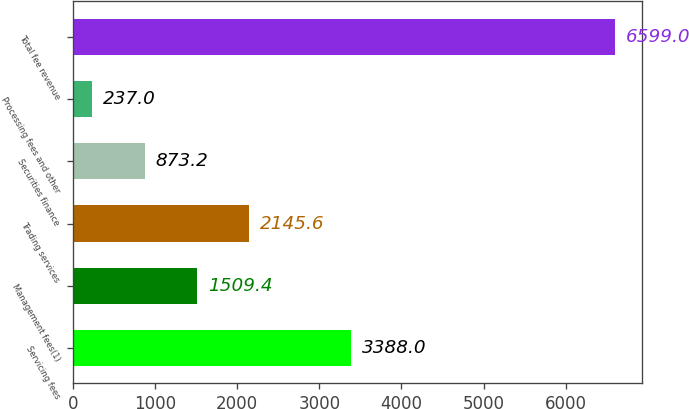Convert chart to OTSL. <chart><loc_0><loc_0><loc_500><loc_500><bar_chart><fcel>Servicing fees<fcel>Management fees(1)<fcel>Trading services<fcel>Securities finance<fcel>Processing fees and other<fcel>Total fee revenue<nl><fcel>3388<fcel>1509.4<fcel>2145.6<fcel>873.2<fcel>237<fcel>6599<nl></chart> 